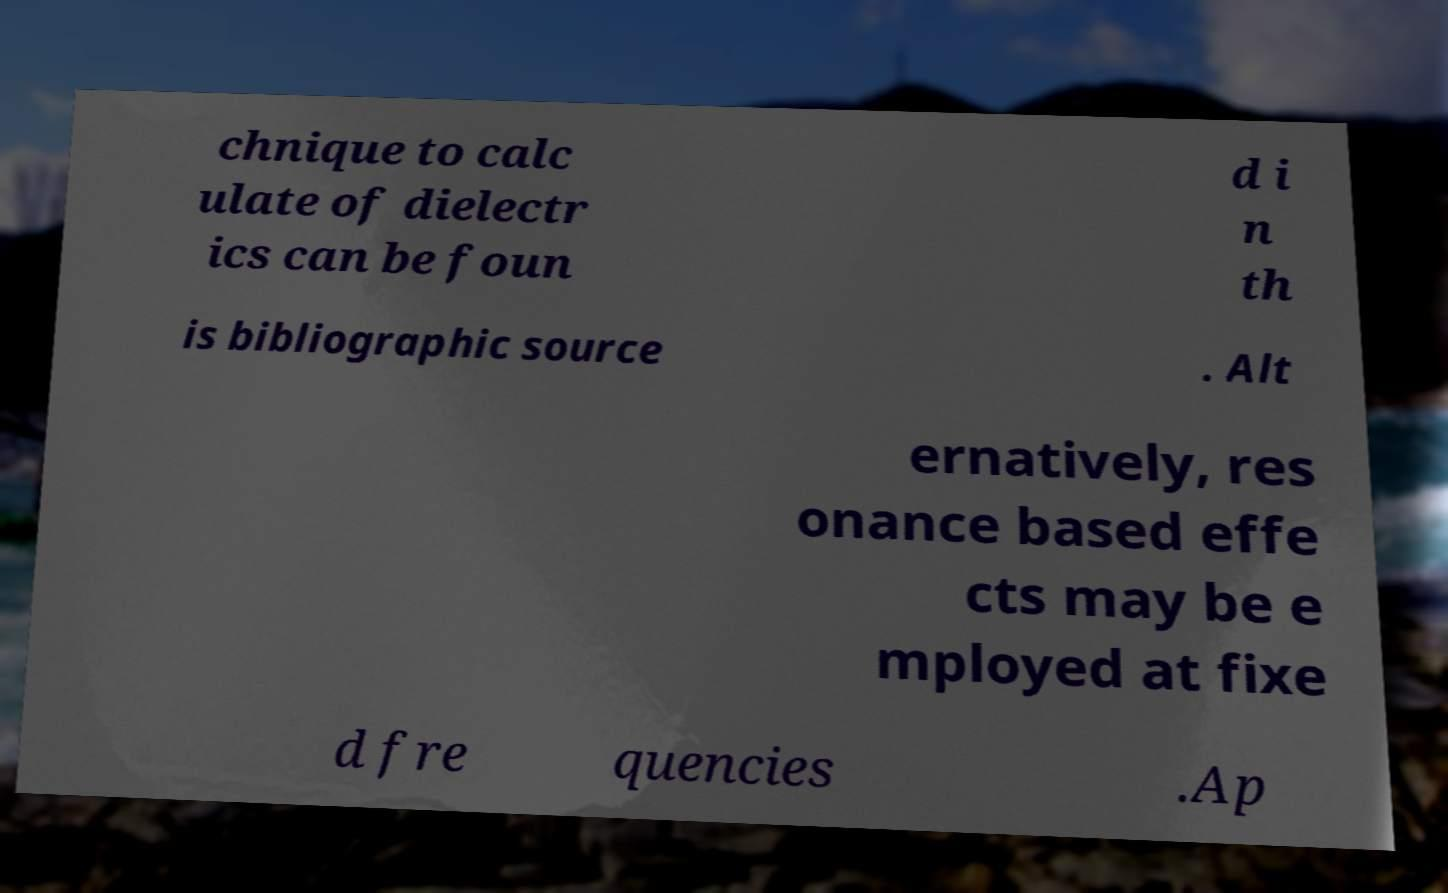What messages or text are displayed in this image? I need them in a readable, typed format. chnique to calc ulate of dielectr ics can be foun d i n th is bibliographic source . Alt ernatively, res onance based effe cts may be e mployed at fixe d fre quencies .Ap 